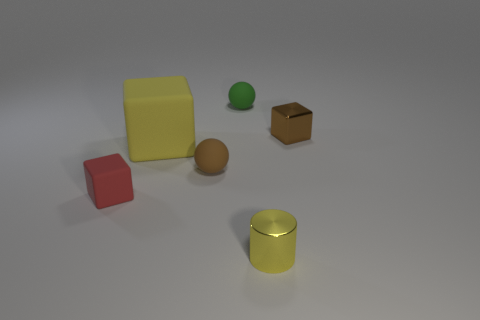There is a brown object in front of the large cube; what material is it?
Offer a terse response. Rubber. There is a small brown metallic object; is it the same shape as the shiny object in front of the yellow cube?
Keep it short and to the point. No. Is the number of tiny red cubes that are left of the tiny red matte block the same as the number of blocks that are in front of the tiny green matte ball?
Your answer should be very brief. No. How many other objects are there of the same material as the green ball?
Offer a very short reply. 3. What number of rubber objects are either red cubes or cylinders?
Your response must be concise. 1. Do the shiny object that is in front of the red rubber object and the red matte object have the same shape?
Offer a terse response. No. Is the number of small green rubber objects on the left side of the big matte block greater than the number of yellow rubber blocks?
Keep it short and to the point. No. How many tiny objects are both to the right of the small yellow shiny cylinder and to the left of the small yellow shiny object?
Offer a very short reply. 0. What color is the tiny object to the left of the rubber block that is right of the small red object?
Your response must be concise. Red. What number of tiny metallic blocks have the same color as the big thing?
Keep it short and to the point. 0. 